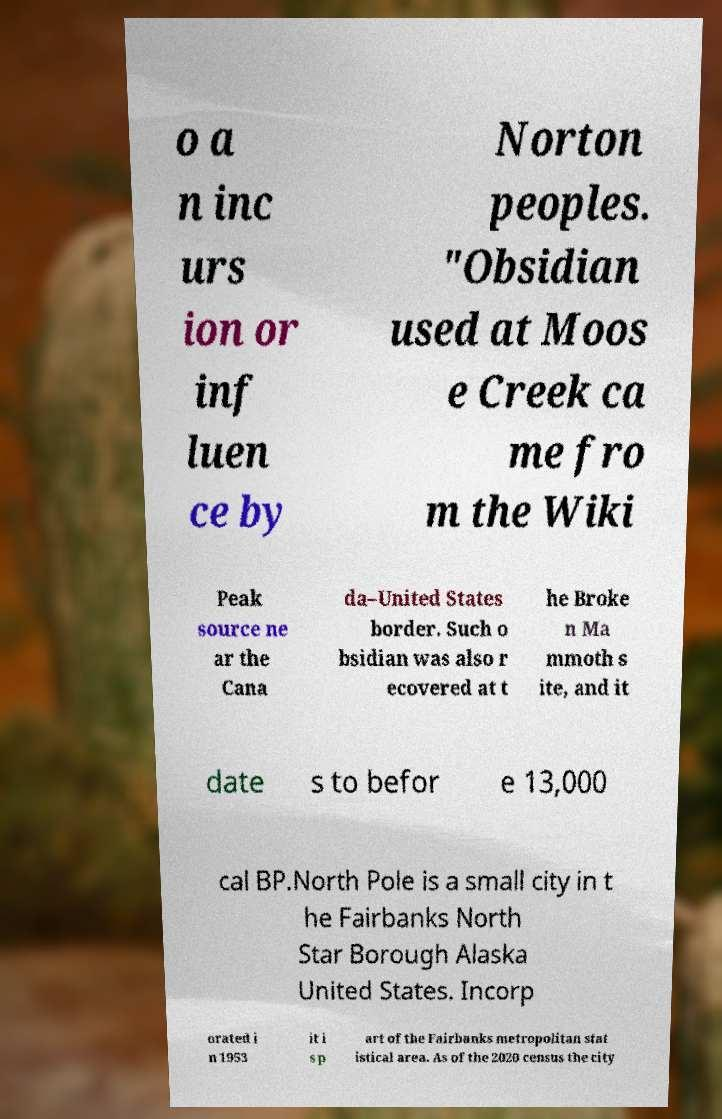Could you extract and type out the text from this image? o a n inc urs ion or inf luen ce by Norton peoples. "Obsidian used at Moos e Creek ca me fro m the Wiki Peak source ne ar the Cana da–United States border. Such o bsidian was also r ecovered at t he Broke n Ma mmoth s ite, and it date s to befor e 13,000 cal BP.North Pole is a small city in t he Fairbanks North Star Borough Alaska United States. Incorp orated i n 1953 it i s p art of the Fairbanks metropolitan stat istical area. As of the 2020 census the city 